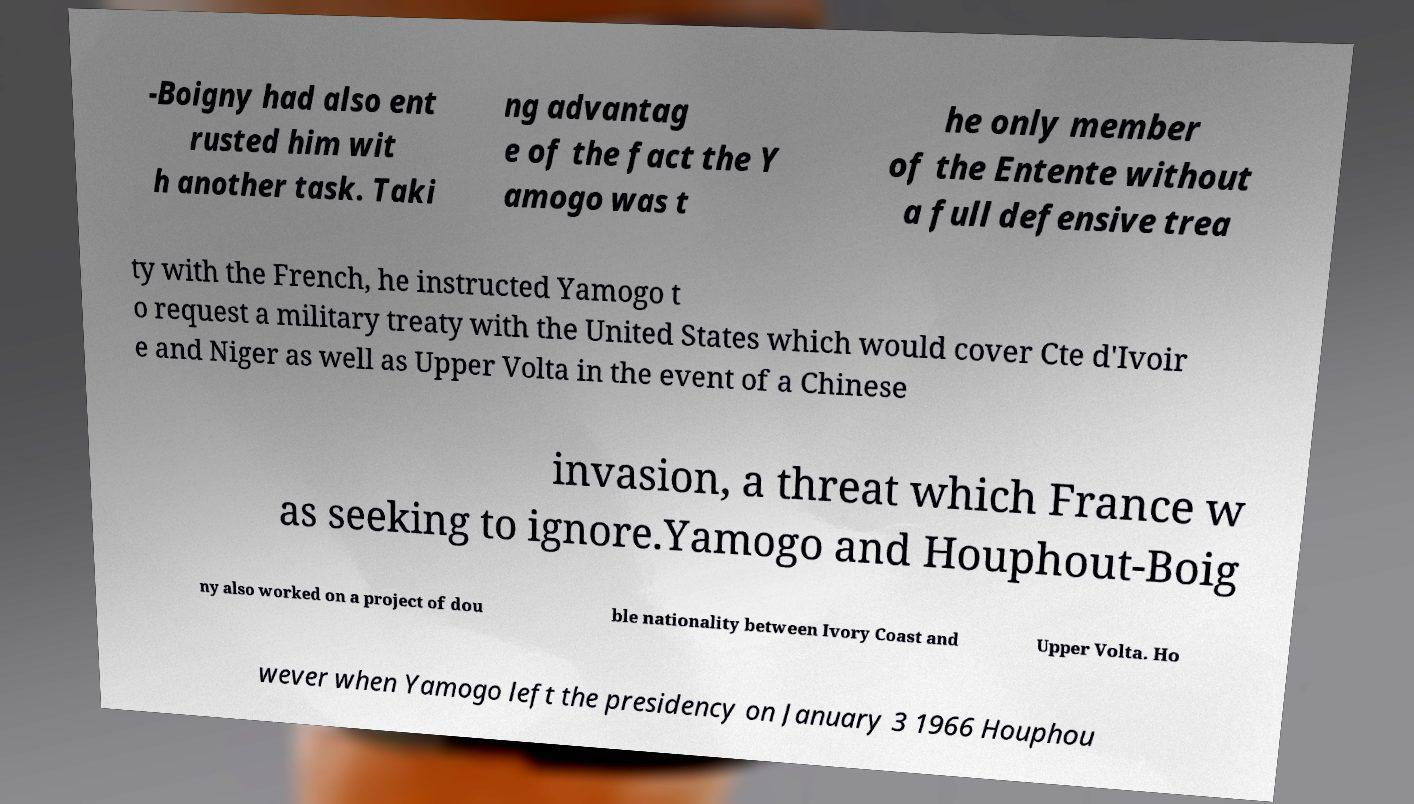What messages or text are displayed in this image? I need them in a readable, typed format. -Boigny had also ent rusted him wit h another task. Taki ng advantag e of the fact the Y amogo was t he only member of the Entente without a full defensive trea ty with the French, he instructed Yamogo t o request a military treaty with the United States which would cover Cte d'Ivoir e and Niger as well as Upper Volta in the event of a Chinese invasion, a threat which France w as seeking to ignore.Yamogo and Houphout-Boig ny also worked on a project of dou ble nationality between Ivory Coast and Upper Volta. Ho wever when Yamogo left the presidency on January 3 1966 Houphou 